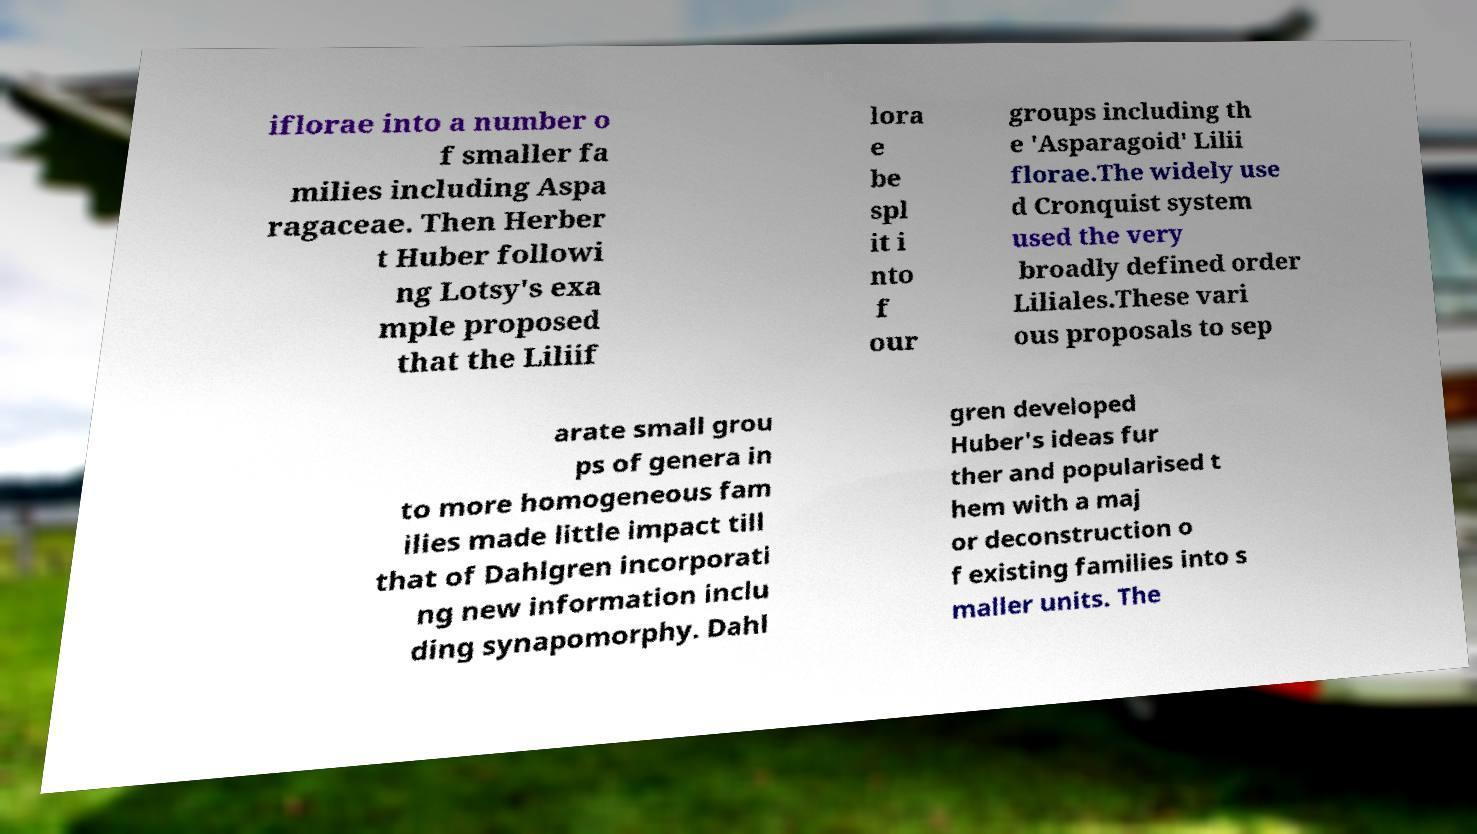I need the written content from this picture converted into text. Can you do that? iflorae into a number o f smaller fa milies including Aspa ragaceae. Then Herber t Huber followi ng Lotsy's exa mple proposed that the Liliif lora e be spl it i nto f our groups including th e 'Asparagoid' Lilii florae.The widely use d Cronquist system used the very broadly defined order Liliales.These vari ous proposals to sep arate small grou ps of genera in to more homogeneous fam ilies made little impact till that of Dahlgren incorporati ng new information inclu ding synapomorphy. Dahl gren developed Huber's ideas fur ther and popularised t hem with a maj or deconstruction o f existing families into s maller units. The 